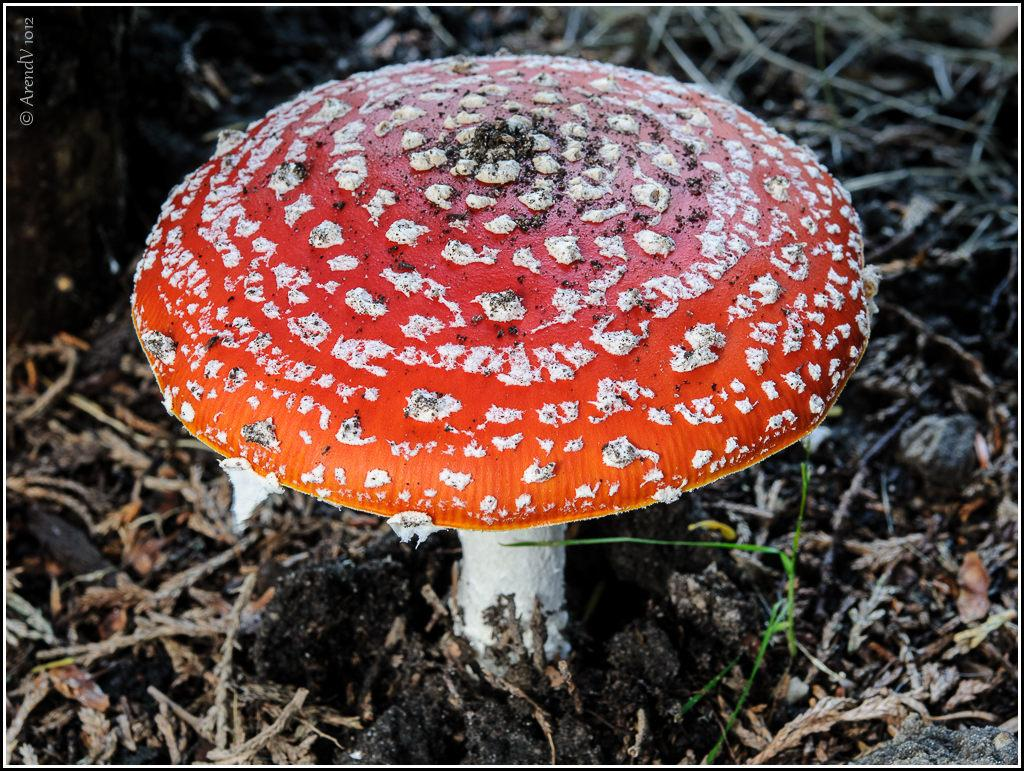What is the main subject of the image? There is a mushroom in the image. What is located at the bottom of the image? There is soil at the bottom of the image. Where is the text in the image? The text is in the top left corner of the image. What type of vegetable is growing next to the mushroom in the image? There is no vegetable present in the image; it only features a mushroom and soil. Does the existence of the mushroom in the image prove the existence of extraterrestrial life? The presence of a mushroom in the image does not provide any information about the existence of extraterrestrial life. 